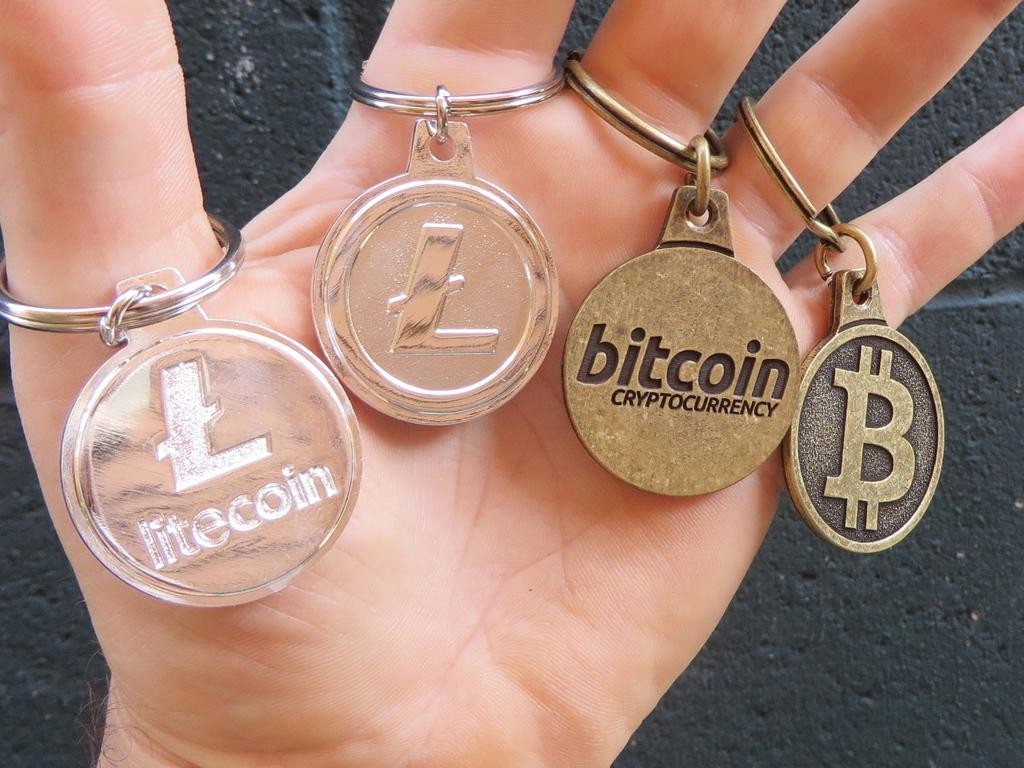<image>
Present a compact description of the photo's key features. Someone holds up several keychains, one that says bitcoin on it 